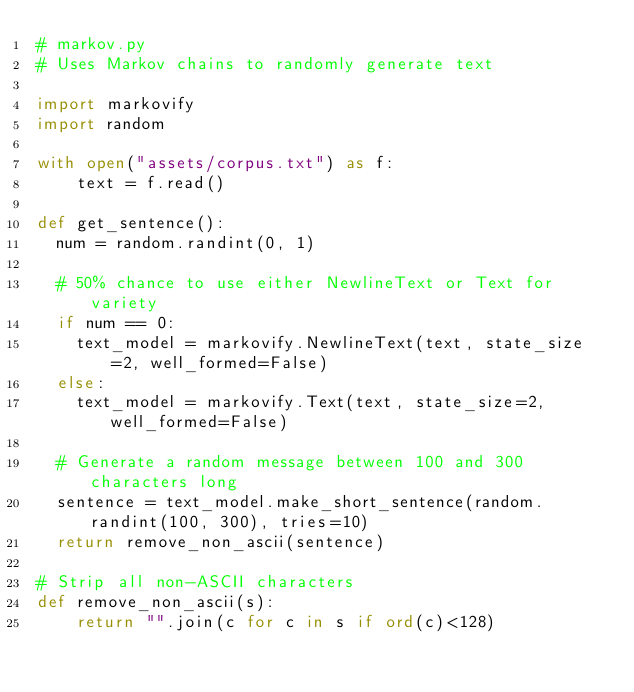<code> <loc_0><loc_0><loc_500><loc_500><_Python_># markov.py
# Uses Markov chains to randomly generate text

import markovify
import random

with open("assets/corpus.txt") as f:
    text = f.read()

def get_sentence():
  num = random.randint(0, 1)

  # 50% chance to use either NewlineText or Text for variety
  if num == 0:
    text_model = markovify.NewlineText(text, state_size=2, well_formed=False)
  else:
    text_model = markovify.Text(text, state_size=2, well_formed=False)

  # Generate a random message between 100 and 300 characters long
  sentence = text_model.make_short_sentence(random.randint(100, 300), tries=10)
  return remove_non_ascii(sentence)

# Strip all non-ASCII characters
def remove_non_ascii(s):
    return "".join(c for c in s if ord(c)<128)</code> 